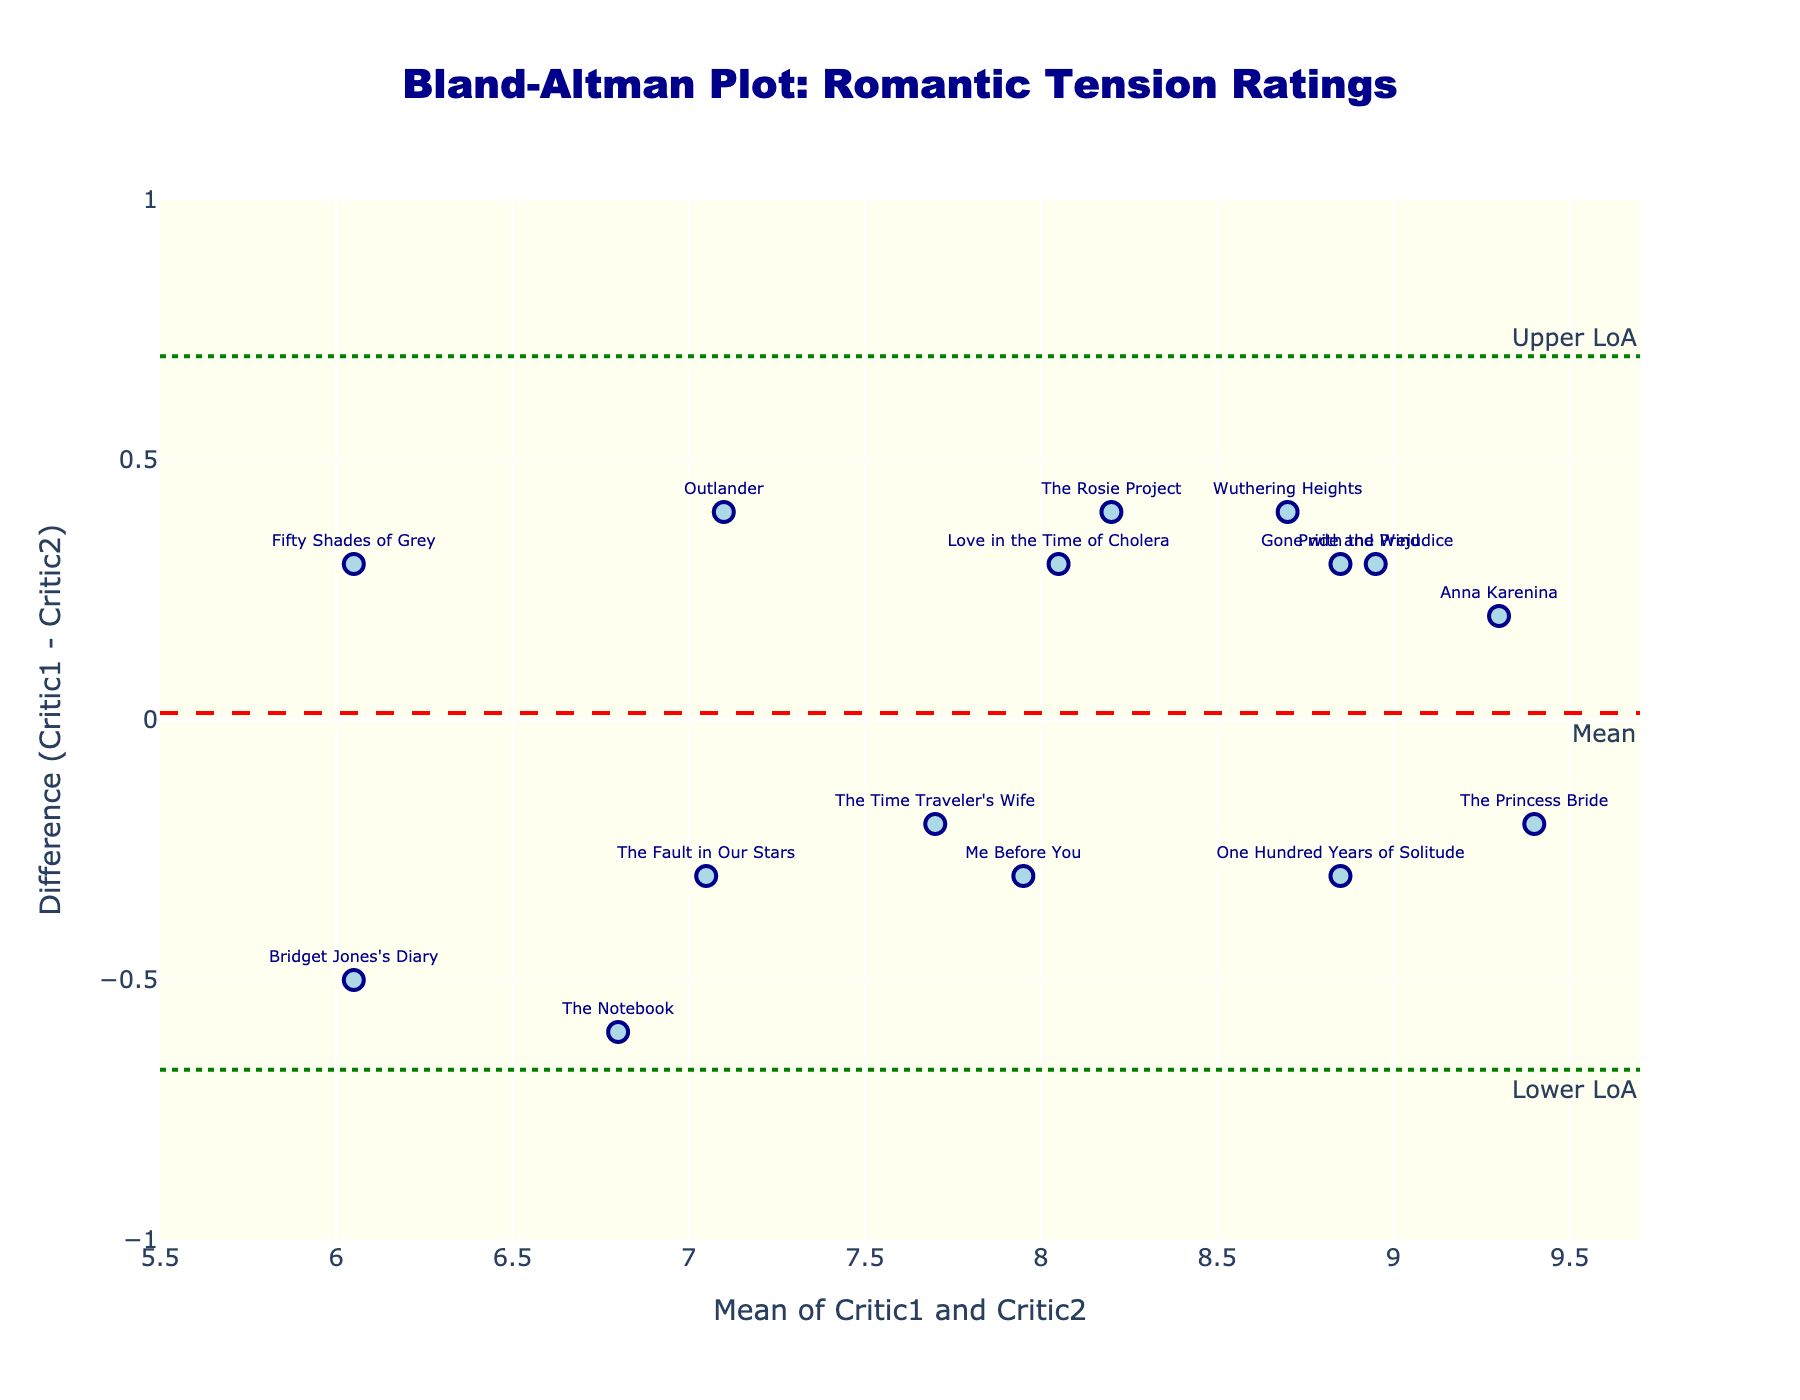What is the title of the plot? The title of the plot is located at the top and states "Bland-Altman Plot: Romantic Tension Ratings". It is displayed prominently in dark blue font.
Answer: Bland-Altman Plot: Romantic Tension Ratings What do the x-axis and y-axis represent? The x-axis is labeled "Mean of Critic1 and Critic2", indicating it represents the average ratings given by both critics. The y-axis is labeled "Difference (Critic1 - Critic2)", showing the difference between Critic1’s and Critic2’s ratings.
Answer: x-axis: Mean of Critic1 and Critic2, y-axis: Difference (Critic1 - Critic2) How many data points are plotted on the figure? Each data point corresponds to a novel, denoted by markers with text labels. By counting the labeled points, there are 15 data points plotted.
Answer: 15 What is the mean difference between Critic1 and Critic2's ratings? The mean difference is shown as a dashed red line with the annotation "Mean" which corresponds to the average of all the differences between Critic1 and Critic2's ratings.
Answer: Mean difference What are the upper and lower limits of agreement? The upper limit of agreement (Upper LoA) is indicated by the dotted green line at the top with the label "Upper LoA". Similarly, the lower limit of agreement (Lower LoA) is depicted by the dotted green line at the bottom with the label "Lower LoA".
Answer: Upper LoA, Lower LoA Which novel has the greatest deviation from the mean difference? To identify this, look at the point with the largest vertical distance from the dashed red line (mean difference). Use the text labels to identify the novel at this point.
Answer: The Notebook How many novels have a difference in ratings that falls outside the limits of agreement? Novels that fall outside the limits of agreement lie beyond the dotted green lines representing the Upper LoA and Lower LoA. Count these points to determine the number.
Answer: 0 Which novel's mean rating by the two critics is the highest, and what is that value? Examine the x-axis to find the data point farthest to the right (representing the highest mean rating). The corresponding text label provides the novel's name, and the x-axis value represents the mean rating.
Answer: Anna Karenina, 9.3 Who tends to rate higher, Critic1 or Critic2? The differences are calculated as Critic1 minus Critic2. Positive differences imply Critic1 rates higher, while negative differences imply Critic2 rates higher. Analyze the distribution of points above and below the y-axis.
Answer: Critics have varied ratings without a clear tendency 